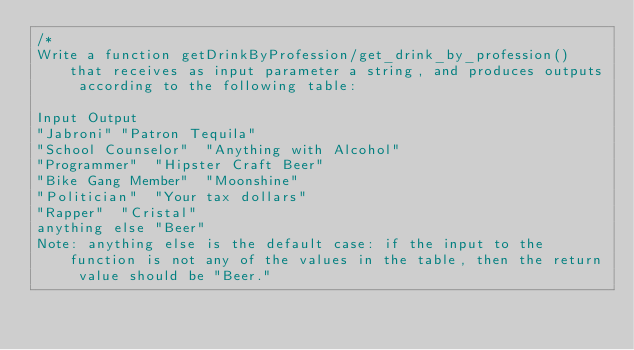<code> <loc_0><loc_0><loc_500><loc_500><_JavaScript_>/*
Write a function getDrinkByProfession/get_drink_by_profession() that receives as input parameter a string, and produces outputs according to the following table:

Input	Output
"Jabroni"	"Patron Tequila"
"School Counselor"	"Anything with Alcohol"
"Programmer"	"Hipster Craft Beer"
"Bike Gang Member"	"Moonshine"
"Politician"	"Your tax dollars"
"Rapper"	"Cristal"
anything else	"Beer"
Note: anything else is the default case: if the input to the function is not any of the values in the table, then the return value should be "Beer."
</code> 